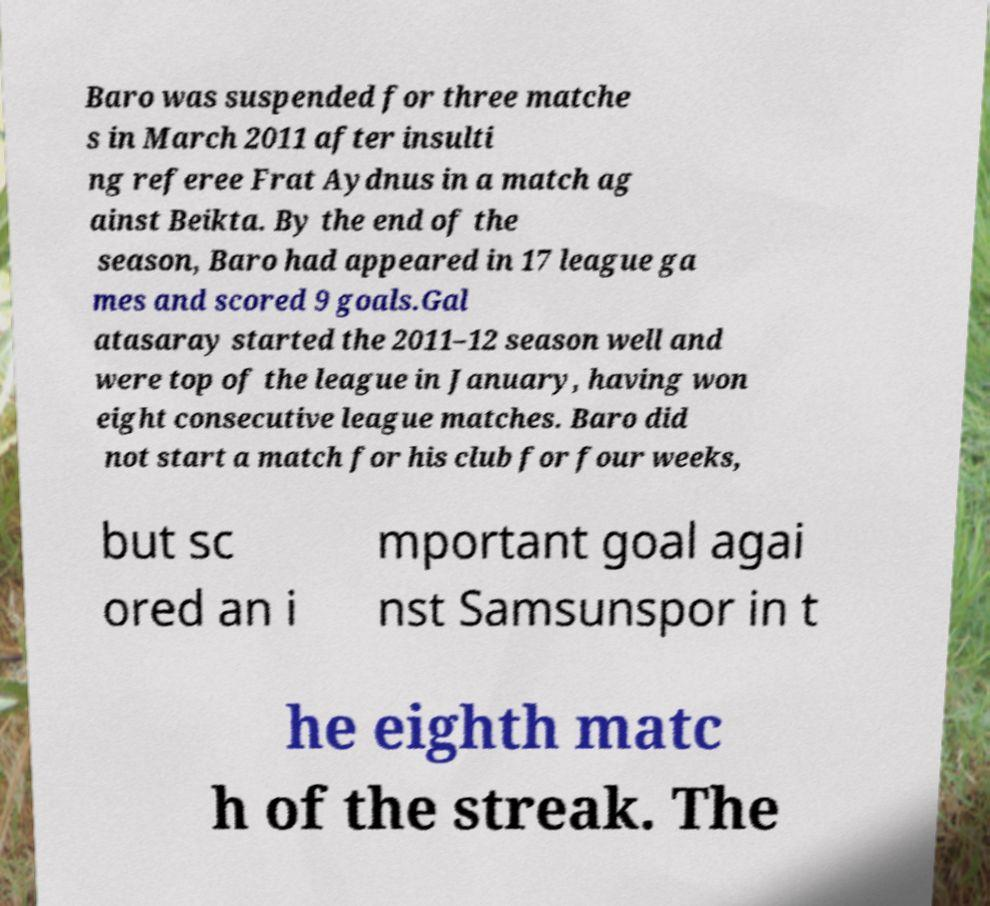Could you extract and type out the text from this image? Baro was suspended for three matche s in March 2011 after insulti ng referee Frat Aydnus in a match ag ainst Beikta. By the end of the season, Baro had appeared in 17 league ga mes and scored 9 goals.Gal atasaray started the 2011–12 season well and were top of the league in January, having won eight consecutive league matches. Baro did not start a match for his club for four weeks, but sc ored an i mportant goal agai nst Samsunspor in t he eighth matc h of the streak. The 